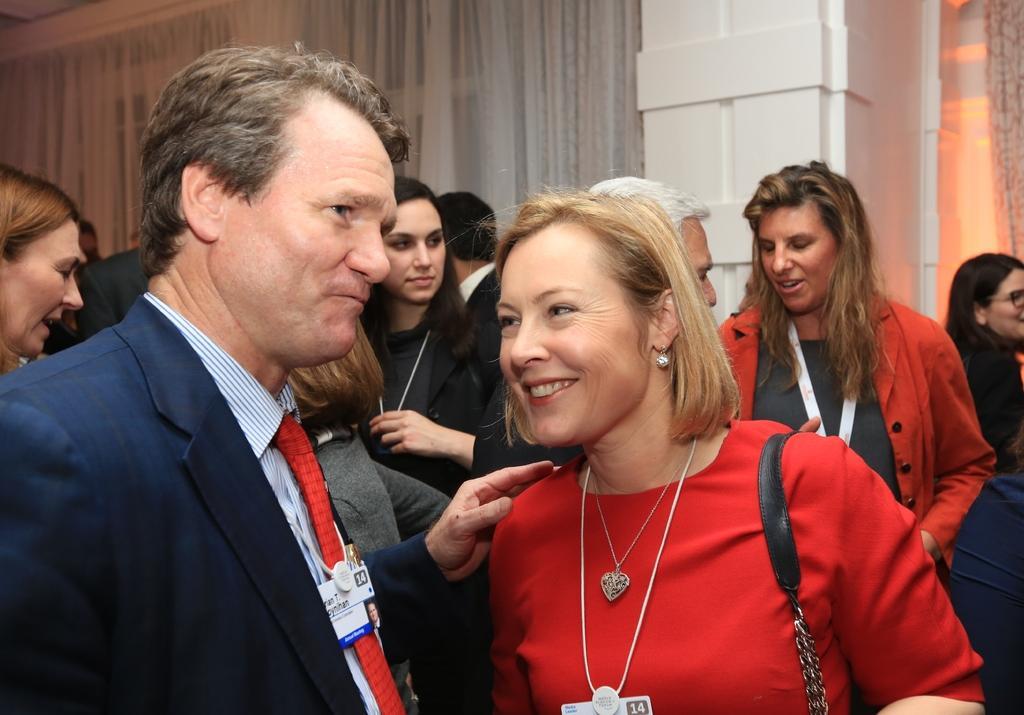Could you give a brief overview of what you see in this image? In this image I can see a person wearing blue colored blazer, red colored tie and a woman wearing red colored dress are standing. In the background I can see a white colored pillar and the curtains. 